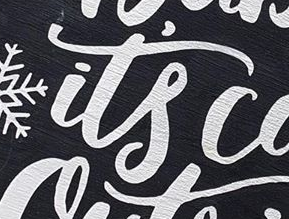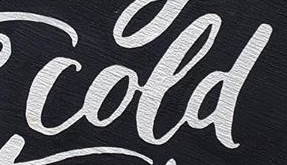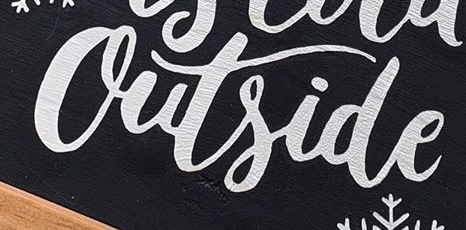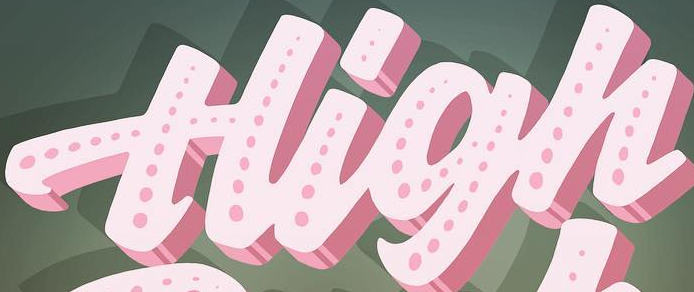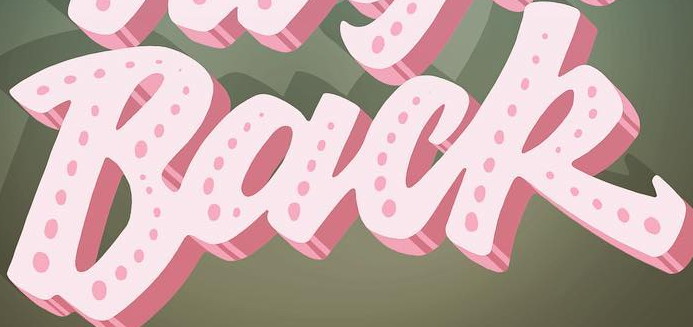What text appears in these images from left to right, separated by a semicolon? it's; cold; Outside; High; Back 